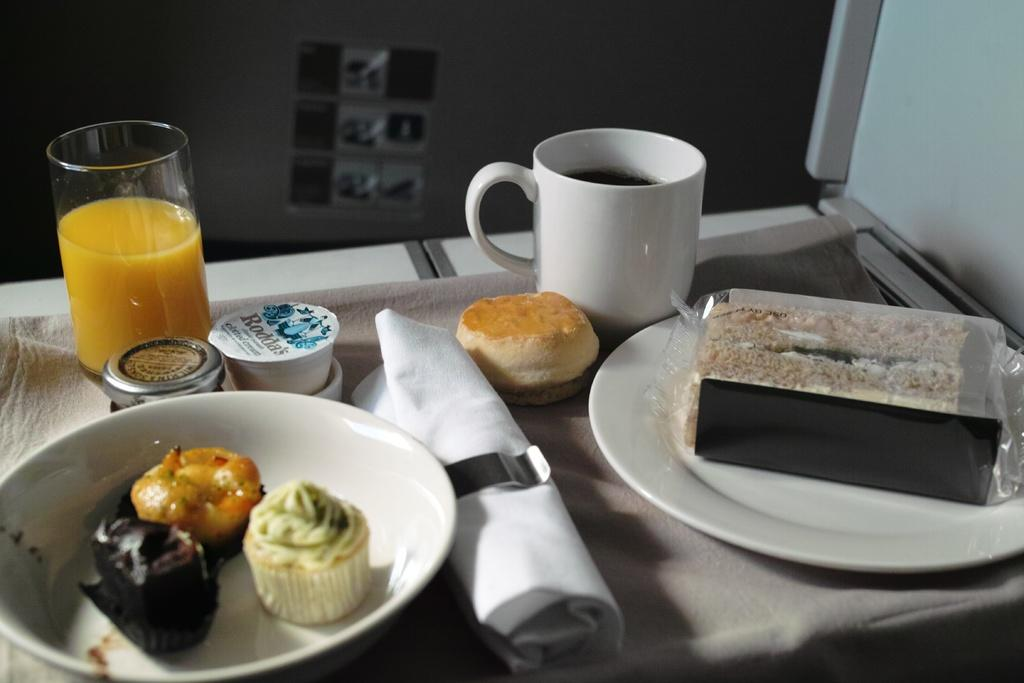What objects in the image are typically used for serving or holding food? There are plates, a cup, and a glass in the image that are used for serving or holding food. What can be found on the plates in the image? There are food items on the plates in the image. What type of material is the cloth made of in the image? The cloth in the image is not described in terms of material, so we cannot determine its composition. What type of marble is visible on the table in the image? There is no marble visible on the table in the image. What role does the servant play in the image? There is no servant present in the image. Is there a gun visible in the image? There is no gun present in the image. 